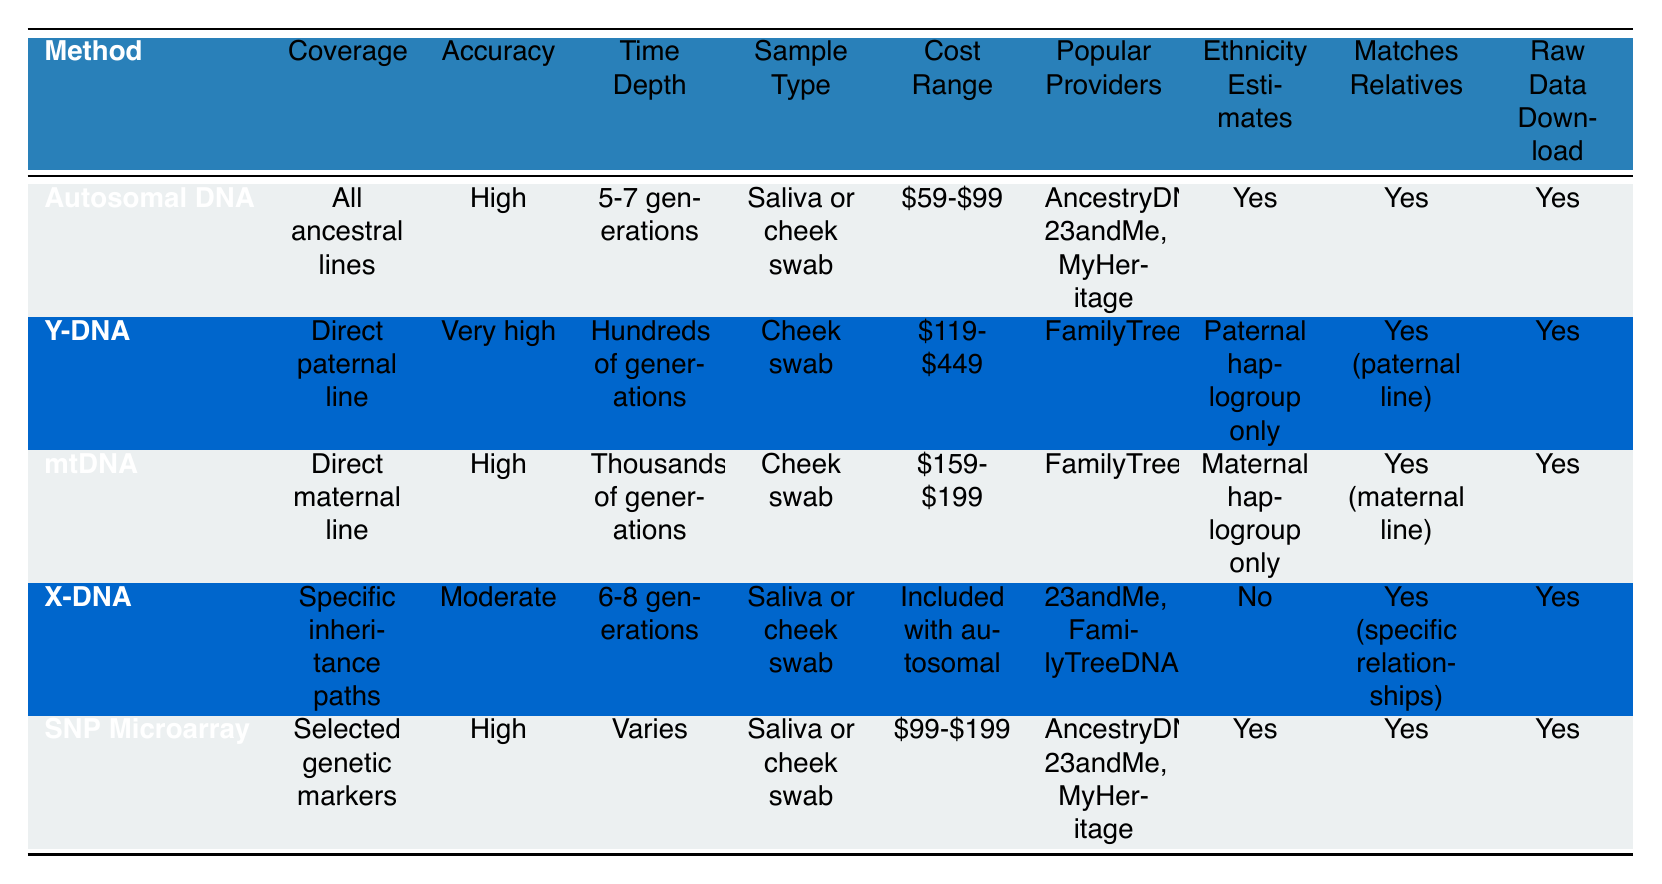What is the cost range for Y-DNA testing? The cost range for Y-DNA testing is listed in the table under the "Cost Range" column. It states "$119-$449."
Answer: $119-$449 Which DNA testing method has the highest accuracy for genealogy? The accuracy for genealogy is detailed in the table, and Y-DNA is marked as "Very high," which is higher than any other method listed.
Answer: Y-DNA How many generations does mtDNA cover, according to the table? The time depth for mtDNA, as shown in the table, is "Thousands of generations," which directly answers the question.
Answer: Thousands of generations Do all DNA testing methods in the table offer raw data download? By checking the "Raw Data Download" column, all methods indicate "Yes," confirming that they offer raw data download.
Answer: Yes Is there a DNA testing method that does not provide ethnicity estimates? The table indicates that X-DNA has "No" in the "Ethnicity Estimates" column, confirming that it does not provide ethnicity estimates.
Answer: Yes What is the average cost range of Autosomal DNA and SNP Microarray testing? The cost ranges are listed as $59-$99 for Autosomal DNA and $99-$199 for SNP Microarray. To find the average, consider the averages of respective ranges: for Autosomal DNA, the average is ($59 + $99)/2 = $79; for SNP Microarray, it is ($99 + $199)/2 = $149. To find the overall average, add both averages ($79 + $149)/2 = $114.
Answer: $114 Which DNA testing method covers all ancestral lines? Referring to the "Coverage" column in the table, Autosomal DNA is specified as covering "All ancestral lines."
Answer: Autosomal DNA What is the time depth for the X-DNA testing method? The "Time Depth" column shows that the time depth for X-DNA is "6-8 generations." This directly answers the question regarding the span it covers.
Answer: 6-8 generations Which method has the lowest cost range? By comparing the cost ranges for all methods, Autosomal DNA has the lowest cost range at "$59-$99."
Answer: Autosomal DNA If you want to trace your direct maternal line, which method should you choose? The coverage for direct maternal line is indicated in the "Coverage" column, where mtDNA is specified for this purpose.
Answer: mtDNA 